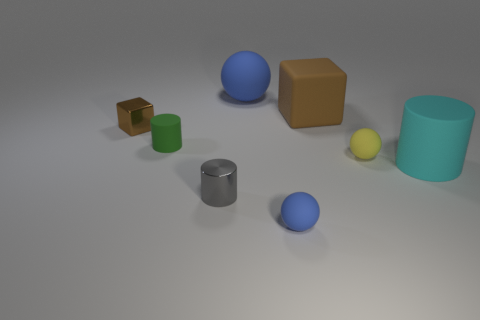What do the simplicity and placement of the objects suggest about the intention behind the image? The simplicity could be intended to focus on the form and color of each item without distraction. The placement of the objects, seemingly random, might suggest an exercise in composition, testing how the eye moves across a scene with varied shapes and colors. 